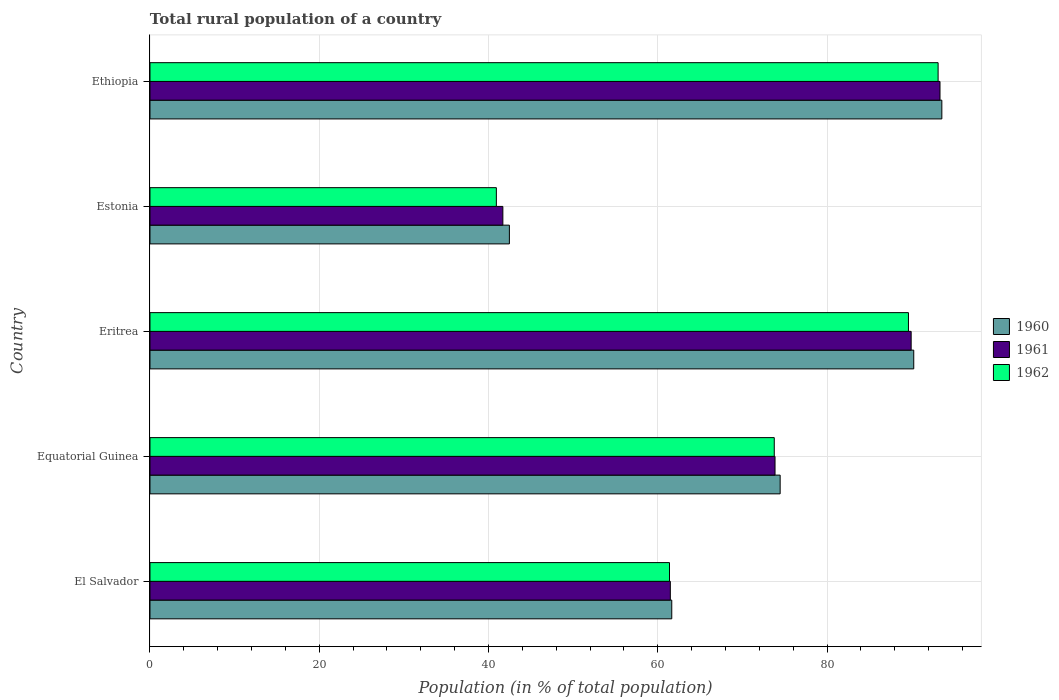How many different coloured bars are there?
Provide a succinct answer. 3. Are the number of bars per tick equal to the number of legend labels?
Ensure brevity in your answer.  Yes. What is the label of the 5th group of bars from the top?
Offer a terse response. El Salvador. In how many cases, is the number of bars for a given country not equal to the number of legend labels?
Ensure brevity in your answer.  0. What is the rural population in 1960 in Ethiopia?
Your answer should be very brief. 93.57. Across all countries, what is the maximum rural population in 1962?
Give a very brief answer. 93.13. Across all countries, what is the minimum rural population in 1962?
Provide a succinct answer. 40.93. In which country was the rural population in 1960 maximum?
Make the answer very short. Ethiopia. In which country was the rural population in 1962 minimum?
Make the answer very short. Estonia. What is the total rural population in 1962 in the graph?
Your answer should be very brief. 358.83. What is the difference between the rural population in 1961 in El Salvador and that in Equatorial Guinea?
Your answer should be very brief. -12.37. What is the difference between the rural population in 1960 in Estonia and the rural population in 1962 in Ethiopia?
Make the answer very short. -50.66. What is the average rural population in 1962 per country?
Your response must be concise. 71.77. What is the difference between the rural population in 1962 and rural population in 1960 in Ethiopia?
Make the answer very short. -0.44. What is the ratio of the rural population in 1960 in Equatorial Guinea to that in Eritrea?
Give a very brief answer. 0.83. Is the rural population in 1962 in Eritrea less than that in Estonia?
Keep it short and to the point. No. What is the difference between the highest and the second highest rural population in 1960?
Your answer should be very brief. 3.32. What is the difference between the highest and the lowest rural population in 1960?
Make the answer very short. 51.1. In how many countries, is the rural population in 1961 greater than the average rural population in 1961 taken over all countries?
Ensure brevity in your answer.  3. Is the sum of the rural population in 1961 in El Salvador and Ethiopia greater than the maximum rural population in 1962 across all countries?
Make the answer very short. Yes. How many bars are there?
Offer a terse response. 15. How many countries are there in the graph?
Make the answer very short. 5. Are the values on the major ticks of X-axis written in scientific E-notation?
Your answer should be compact. No. Where does the legend appear in the graph?
Ensure brevity in your answer.  Center right. How many legend labels are there?
Offer a very short reply. 3. How are the legend labels stacked?
Your response must be concise. Vertical. What is the title of the graph?
Offer a terse response. Total rural population of a country. Does "2015" appear as one of the legend labels in the graph?
Give a very brief answer. No. What is the label or title of the X-axis?
Offer a very short reply. Population (in % of total population). What is the Population (in % of total population) in 1960 in El Salvador?
Give a very brief answer. 61.66. What is the Population (in % of total population) of 1961 in El Salvador?
Make the answer very short. 61.48. What is the Population (in % of total population) in 1962 in El Salvador?
Provide a short and direct response. 61.39. What is the Population (in % of total population) of 1960 in Equatorial Guinea?
Provide a succinct answer. 74.46. What is the Population (in % of total population) of 1961 in Equatorial Guinea?
Make the answer very short. 73.86. What is the Population (in % of total population) in 1962 in Equatorial Guinea?
Keep it short and to the point. 73.77. What is the Population (in % of total population) in 1960 in Eritrea?
Offer a very short reply. 90.25. What is the Population (in % of total population) in 1961 in Eritrea?
Offer a terse response. 89.94. What is the Population (in % of total population) in 1962 in Eritrea?
Offer a very short reply. 89.62. What is the Population (in % of total population) of 1960 in Estonia?
Provide a short and direct response. 42.47. What is the Population (in % of total population) in 1961 in Estonia?
Your answer should be compact. 41.7. What is the Population (in % of total population) in 1962 in Estonia?
Provide a short and direct response. 40.93. What is the Population (in % of total population) of 1960 in Ethiopia?
Provide a succinct answer. 93.57. What is the Population (in % of total population) of 1961 in Ethiopia?
Give a very brief answer. 93.35. What is the Population (in % of total population) of 1962 in Ethiopia?
Keep it short and to the point. 93.13. Across all countries, what is the maximum Population (in % of total population) of 1960?
Give a very brief answer. 93.57. Across all countries, what is the maximum Population (in % of total population) in 1961?
Your response must be concise. 93.35. Across all countries, what is the maximum Population (in % of total population) in 1962?
Your answer should be compact. 93.13. Across all countries, what is the minimum Population (in % of total population) in 1960?
Make the answer very short. 42.47. Across all countries, what is the minimum Population (in % of total population) in 1961?
Offer a very short reply. 41.7. Across all countries, what is the minimum Population (in % of total population) of 1962?
Offer a terse response. 40.93. What is the total Population (in % of total population) of 1960 in the graph?
Your answer should be very brief. 362.4. What is the total Population (in % of total population) in 1961 in the graph?
Ensure brevity in your answer.  360.33. What is the total Population (in % of total population) in 1962 in the graph?
Give a very brief answer. 358.83. What is the difference between the Population (in % of total population) of 1960 in El Salvador and that in Equatorial Guinea?
Give a very brief answer. -12.81. What is the difference between the Population (in % of total population) of 1961 in El Salvador and that in Equatorial Guinea?
Keep it short and to the point. -12.37. What is the difference between the Population (in % of total population) of 1962 in El Salvador and that in Equatorial Guinea?
Provide a short and direct response. -12.38. What is the difference between the Population (in % of total population) in 1960 in El Salvador and that in Eritrea?
Give a very brief answer. -28.59. What is the difference between the Population (in % of total population) of 1961 in El Salvador and that in Eritrea?
Provide a succinct answer. -28.46. What is the difference between the Population (in % of total population) in 1962 in El Salvador and that in Eritrea?
Provide a succinct answer. -28.24. What is the difference between the Population (in % of total population) in 1960 in El Salvador and that in Estonia?
Give a very brief answer. 19.19. What is the difference between the Population (in % of total population) in 1961 in El Salvador and that in Estonia?
Give a very brief answer. 19.79. What is the difference between the Population (in % of total population) of 1962 in El Salvador and that in Estonia?
Offer a very short reply. 20.46. What is the difference between the Population (in % of total population) of 1960 in El Salvador and that in Ethiopia?
Offer a very short reply. -31.91. What is the difference between the Population (in % of total population) of 1961 in El Salvador and that in Ethiopia?
Ensure brevity in your answer.  -31.87. What is the difference between the Population (in % of total population) of 1962 in El Salvador and that in Ethiopia?
Give a very brief answer. -31.74. What is the difference between the Population (in % of total population) of 1960 in Equatorial Guinea and that in Eritrea?
Your answer should be compact. -15.79. What is the difference between the Population (in % of total population) in 1961 in Equatorial Guinea and that in Eritrea?
Offer a very short reply. -16.09. What is the difference between the Population (in % of total population) in 1962 in Equatorial Guinea and that in Eritrea?
Ensure brevity in your answer.  -15.86. What is the difference between the Population (in % of total population) of 1960 in Equatorial Guinea and that in Estonia?
Offer a terse response. 32. What is the difference between the Population (in % of total population) in 1961 in Equatorial Guinea and that in Estonia?
Your answer should be compact. 32.16. What is the difference between the Population (in % of total population) of 1962 in Equatorial Guinea and that in Estonia?
Your answer should be very brief. 32.84. What is the difference between the Population (in % of total population) of 1960 in Equatorial Guinea and that in Ethiopia?
Your answer should be compact. -19.1. What is the difference between the Population (in % of total population) in 1961 in Equatorial Guinea and that in Ethiopia?
Offer a very short reply. -19.49. What is the difference between the Population (in % of total population) in 1962 in Equatorial Guinea and that in Ethiopia?
Your response must be concise. -19.36. What is the difference between the Population (in % of total population) of 1960 in Eritrea and that in Estonia?
Give a very brief answer. 47.78. What is the difference between the Population (in % of total population) of 1961 in Eritrea and that in Estonia?
Offer a terse response. 48.24. What is the difference between the Population (in % of total population) of 1962 in Eritrea and that in Estonia?
Your response must be concise. 48.7. What is the difference between the Population (in % of total population) of 1960 in Eritrea and that in Ethiopia?
Your answer should be compact. -3.32. What is the difference between the Population (in % of total population) of 1961 in Eritrea and that in Ethiopia?
Your answer should be compact. -3.41. What is the difference between the Population (in % of total population) in 1962 in Eritrea and that in Ethiopia?
Keep it short and to the point. -3.5. What is the difference between the Population (in % of total population) in 1960 in Estonia and that in Ethiopia?
Make the answer very short. -51.1. What is the difference between the Population (in % of total population) of 1961 in Estonia and that in Ethiopia?
Offer a very short reply. -51.65. What is the difference between the Population (in % of total population) of 1962 in Estonia and that in Ethiopia?
Offer a very short reply. -52.2. What is the difference between the Population (in % of total population) of 1960 in El Salvador and the Population (in % of total population) of 1961 in Equatorial Guinea?
Make the answer very short. -12.2. What is the difference between the Population (in % of total population) in 1960 in El Salvador and the Population (in % of total population) in 1962 in Equatorial Guinea?
Provide a succinct answer. -12.11. What is the difference between the Population (in % of total population) in 1961 in El Salvador and the Population (in % of total population) in 1962 in Equatorial Guinea?
Ensure brevity in your answer.  -12.28. What is the difference between the Population (in % of total population) in 1960 in El Salvador and the Population (in % of total population) in 1961 in Eritrea?
Your response must be concise. -28.29. What is the difference between the Population (in % of total population) in 1960 in El Salvador and the Population (in % of total population) in 1962 in Eritrea?
Your answer should be compact. -27.97. What is the difference between the Population (in % of total population) in 1961 in El Salvador and the Population (in % of total population) in 1962 in Eritrea?
Provide a succinct answer. -28.14. What is the difference between the Population (in % of total population) in 1960 in El Salvador and the Population (in % of total population) in 1961 in Estonia?
Ensure brevity in your answer.  19.96. What is the difference between the Population (in % of total population) of 1960 in El Salvador and the Population (in % of total population) of 1962 in Estonia?
Provide a short and direct response. 20.73. What is the difference between the Population (in % of total population) of 1961 in El Salvador and the Population (in % of total population) of 1962 in Estonia?
Ensure brevity in your answer.  20.56. What is the difference between the Population (in % of total population) of 1960 in El Salvador and the Population (in % of total population) of 1961 in Ethiopia?
Your answer should be compact. -31.7. What is the difference between the Population (in % of total population) in 1960 in El Salvador and the Population (in % of total population) in 1962 in Ethiopia?
Provide a short and direct response. -31.47. What is the difference between the Population (in % of total population) of 1961 in El Salvador and the Population (in % of total population) of 1962 in Ethiopia?
Your answer should be very brief. -31.64. What is the difference between the Population (in % of total population) in 1960 in Equatorial Guinea and the Population (in % of total population) in 1961 in Eritrea?
Offer a very short reply. -15.48. What is the difference between the Population (in % of total population) of 1960 in Equatorial Guinea and the Population (in % of total population) of 1962 in Eritrea?
Ensure brevity in your answer.  -15.16. What is the difference between the Population (in % of total population) of 1961 in Equatorial Guinea and the Population (in % of total population) of 1962 in Eritrea?
Your response must be concise. -15.77. What is the difference between the Population (in % of total population) in 1960 in Equatorial Guinea and the Population (in % of total population) in 1961 in Estonia?
Offer a terse response. 32.77. What is the difference between the Population (in % of total population) in 1960 in Equatorial Guinea and the Population (in % of total population) in 1962 in Estonia?
Ensure brevity in your answer.  33.53. What is the difference between the Population (in % of total population) in 1961 in Equatorial Guinea and the Population (in % of total population) in 1962 in Estonia?
Ensure brevity in your answer.  32.93. What is the difference between the Population (in % of total population) of 1960 in Equatorial Guinea and the Population (in % of total population) of 1961 in Ethiopia?
Offer a terse response. -18.89. What is the difference between the Population (in % of total population) in 1960 in Equatorial Guinea and the Population (in % of total population) in 1962 in Ethiopia?
Keep it short and to the point. -18.66. What is the difference between the Population (in % of total population) of 1961 in Equatorial Guinea and the Population (in % of total population) of 1962 in Ethiopia?
Make the answer very short. -19.27. What is the difference between the Population (in % of total population) of 1960 in Eritrea and the Population (in % of total population) of 1961 in Estonia?
Offer a very short reply. 48.55. What is the difference between the Population (in % of total population) of 1960 in Eritrea and the Population (in % of total population) of 1962 in Estonia?
Your answer should be very brief. 49.32. What is the difference between the Population (in % of total population) in 1961 in Eritrea and the Population (in % of total population) in 1962 in Estonia?
Ensure brevity in your answer.  49.01. What is the difference between the Population (in % of total population) in 1960 in Eritrea and the Population (in % of total population) in 1961 in Ethiopia?
Your answer should be very brief. -3.1. What is the difference between the Population (in % of total population) in 1960 in Eritrea and the Population (in % of total population) in 1962 in Ethiopia?
Offer a very short reply. -2.88. What is the difference between the Population (in % of total population) in 1961 in Eritrea and the Population (in % of total population) in 1962 in Ethiopia?
Your response must be concise. -3.19. What is the difference between the Population (in % of total population) of 1960 in Estonia and the Population (in % of total population) of 1961 in Ethiopia?
Your answer should be very brief. -50.88. What is the difference between the Population (in % of total population) of 1960 in Estonia and the Population (in % of total population) of 1962 in Ethiopia?
Ensure brevity in your answer.  -50.66. What is the difference between the Population (in % of total population) of 1961 in Estonia and the Population (in % of total population) of 1962 in Ethiopia?
Your answer should be compact. -51.43. What is the average Population (in % of total population) of 1960 per country?
Ensure brevity in your answer.  72.48. What is the average Population (in % of total population) in 1961 per country?
Offer a terse response. 72.07. What is the average Population (in % of total population) in 1962 per country?
Your answer should be very brief. 71.77. What is the difference between the Population (in % of total population) in 1960 and Population (in % of total population) in 1961 in El Salvador?
Your answer should be very brief. 0.17. What is the difference between the Population (in % of total population) in 1960 and Population (in % of total population) in 1962 in El Salvador?
Offer a very short reply. 0.27. What is the difference between the Population (in % of total population) of 1961 and Population (in % of total population) of 1962 in El Salvador?
Ensure brevity in your answer.  0.1. What is the difference between the Population (in % of total population) in 1960 and Population (in % of total population) in 1961 in Equatorial Guinea?
Your answer should be very brief. 0.61. What is the difference between the Population (in % of total population) in 1960 and Population (in % of total population) in 1962 in Equatorial Guinea?
Offer a terse response. 0.7. What is the difference between the Population (in % of total population) of 1961 and Population (in % of total population) of 1962 in Equatorial Guinea?
Your answer should be very brief. 0.09. What is the difference between the Population (in % of total population) in 1960 and Population (in % of total population) in 1961 in Eritrea?
Your response must be concise. 0.31. What is the difference between the Population (in % of total population) in 1960 and Population (in % of total population) in 1962 in Eritrea?
Give a very brief answer. 0.63. What is the difference between the Population (in % of total population) of 1961 and Population (in % of total population) of 1962 in Eritrea?
Your response must be concise. 0.32. What is the difference between the Population (in % of total population) of 1960 and Population (in % of total population) of 1961 in Estonia?
Your answer should be very brief. 0.77. What is the difference between the Population (in % of total population) of 1960 and Population (in % of total population) of 1962 in Estonia?
Your answer should be compact. 1.54. What is the difference between the Population (in % of total population) of 1961 and Population (in % of total population) of 1962 in Estonia?
Make the answer very short. 0.77. What is the difference between the Population (in % of total population) in 1960 and Population (in % of total population) in 1961 in Ethiopia?
Ensure brevity in your answer.  0.22. What is the difference between the Population (in % of total population) in 1960 and Population (in % of total population) in 1962 in Ethiopia?
Offer a terse response. 0.44. What is the difference between the Population (in % of total population) of 1961 and Population (in % of total population) of 1962 in Ethiopia?
Your answer should be very brief. 0.22. What is the ratio of the Population (in % of total population) in 1960 in El Salvador to that in Equatorial Guinea?
Provide a short and direct response. 0.83. What is the ratio of the Population (in % of total population) in 1961 in El Salvador to that in Equatorial Guinea?
Keep it short and to the point. 0.83. What is the ratio of the Population (in % of total population) in 1962 in El Salvador to that in Equatorial Guinea?
Your answer should be very brief. 0.83. What is the ratio of the Population (in % of total population) of 1960 in El Salvador to that in Eritrea?
Provide a succinct answer. 0.68. What is the ratio of the Population (in % of total population) in 1961 in El Salvador to that in Eritrea?
Ensure brevity in your answer.  0.68. What is the ratio of the Population (in % of total population) of 1962 in El Salvador to that in Eritrea?
Give a very brief answer. 0.68. What is the ratio of the Population (in % of total population) in 1960 in El Salvador to that in Estonia?
Your answer should be compact. 1.45. What is the ratio of the Population (in % of total population) of 1961 in El Salvador to that in Estonia?
Offer a terse response. 1.47. What is the ratio of the Population (in % of total population) in 1962 in El Salvador to that in Estonia?
Provide a succinct answer. 1.5. What is the ratio of the Population (in % of total population) in 1960 in El Salvador to that in Ethiopia?
Provide a short and direct response. 0.66. What is the ratio of the Population (in % of total population) in 1961 in El Salvador to that in Ethiopia?
Give a very brief answer. 0.66. What is the ratio of the Population (in % of total population) in 1962 in El Salvador to that in Ethiopia?
Your answer should be compact. 0.66. What is the ratio of the Population (in % of total population) in 1960 in Equatorial Guinea to that in Eritrea?
Make the answer very short. 0.83. What is the ratio of the Population (in % of total population) of 1961 in Equatorial Guinea to that in Eritrea?
Offer a terse response. 0.82. What is the ratio of the Population (in % of total population) of 1962 in Equatorial Guinea to that in Eritrea?
Keep it short and to the point. 0.82. What is the ratio of the Population (in % of total population) in 1960 in Equatorial Guinea to that in Estonia?
Make the answer very short. 1.75. What is the ratio of the Population (in % of total population) in 1961 in Equatorial Guinea to that in Estonia?
Your response must be concise. 1.77. What is the ratio of the Population (in % of total population) of 1962 in Equatorial Guinea to that in Estonia?
Ensure brevity in your answer.  1.8. What is the ratio of the Population (in % of total population) of 1960 in Equatorial Guinea to that in Ethiopia?
Your answer should be compact. 0.8. What is the ratio of the Population (in % of total population) of 1961 in Equatorial Guinea to that in Ethiopia?
Make the answer very short. 0.79. What is the ratio of the Population (in % of total population) in 1962 in Equatorial Guinea to that in Ethiopia?
Keep it short and to the point. 0.79. What is the ratio of the Population (in % of total population) in 1960 in Eritrea to that in Estonia?
Offer a terse response. 2.13. What is the ratio of the Population (in % of total population) of 1961 in Eritrea to that in Estonia?
Offer a terse response. 2.16. What is the ratio of the Population (in % of total population) in 1962 in Eritrea to that in Estonia?
Your response must be concise. 2.19. What is the ratio of the Population (in % of total population) of 1960 in Eritrea to that in Ethiopia?
Your response must be concise. 0.96. What is the ratio of the Population (in % of total population) in 1961 in Eritrea to that in Ethiopia?
Offer a terse response. 0.96. What is the ratio of the Population (in % of total population) in 1962 in Eritrea to that in Ethiopia?
Offer a very short reply. 0.96. What is the ratio of the Population (in % of total population) in 1960 in Estonia to that in Ethiopia?
Provide a succinct answer. 0.45. What is the ratio of the Population (in % of total population) of 1961 in Estonia to that in Ethiopia?
Make the answer very short. 0.45. What is the ratio of the Population (in % of total population) in 1962 in Estonia to that in Ethiopia?
Give a very brief answer. 0.44. What is the difference between the highest and the second highest Population (in % of total population) of 1960?
Your answer should be very brief. 3.32. What is the difference between the highest and the second highest Population (in % of total population) of 1961?
Provide a short and direct response. 3.41. What is the difference between the highest and the second highest Population (in % of total population) in 1962?
Make the answer very short. 3.5. What is the difference between the highest and the lowest Population (in % of total population) of 1960?
Provide a succinct answer. 51.1. What is the difference between the highest and the lowest Population (in % of total population) in 1961?
Provide a short and direct response. 51.65. What is the difference between the highest and the lowest Population (in % of total population) of 1962?
Provide a short and direct response. 52.2. 